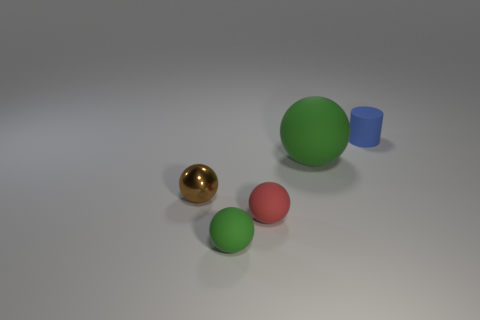Is there a cyan object that has the same size as the red rubber sphere?
Offer a terse response. No. What color is the small ball that is on the left side of the tiny green matte thing?
Make the answer very short. Brown. There is a tiny object that is both behind the tiny red sphere and to the right of the metallic thing; what shape is it?
Keep it short and to the point. Cylinder. How many other tiny rubber objects are the same shape as the tiny brown thing?
Your response must be concise. 2. What number of shiny things are there?
Your response must be concise. 1. There is a rubber object that is to the left of the blue cylinder and behind the brown metal sphere; what is its size?
Offer a very short reply. Large. What is the shape of the red object that is the same size as the blue matte cylinder?
Your response must be concise. Sphere. There is a green ball on the left side of the large green object; is there a big object right of it?
Your answer should be compact. Yes. What color is the other large thing that is the same shape as the brown object?
Ensure brevity in your answer.  Green. There is a tiny rubber sphere that is left of the red rubber sphere; is its color the same as the big rubber sphere?
Provide a succinct answer. Yes. 